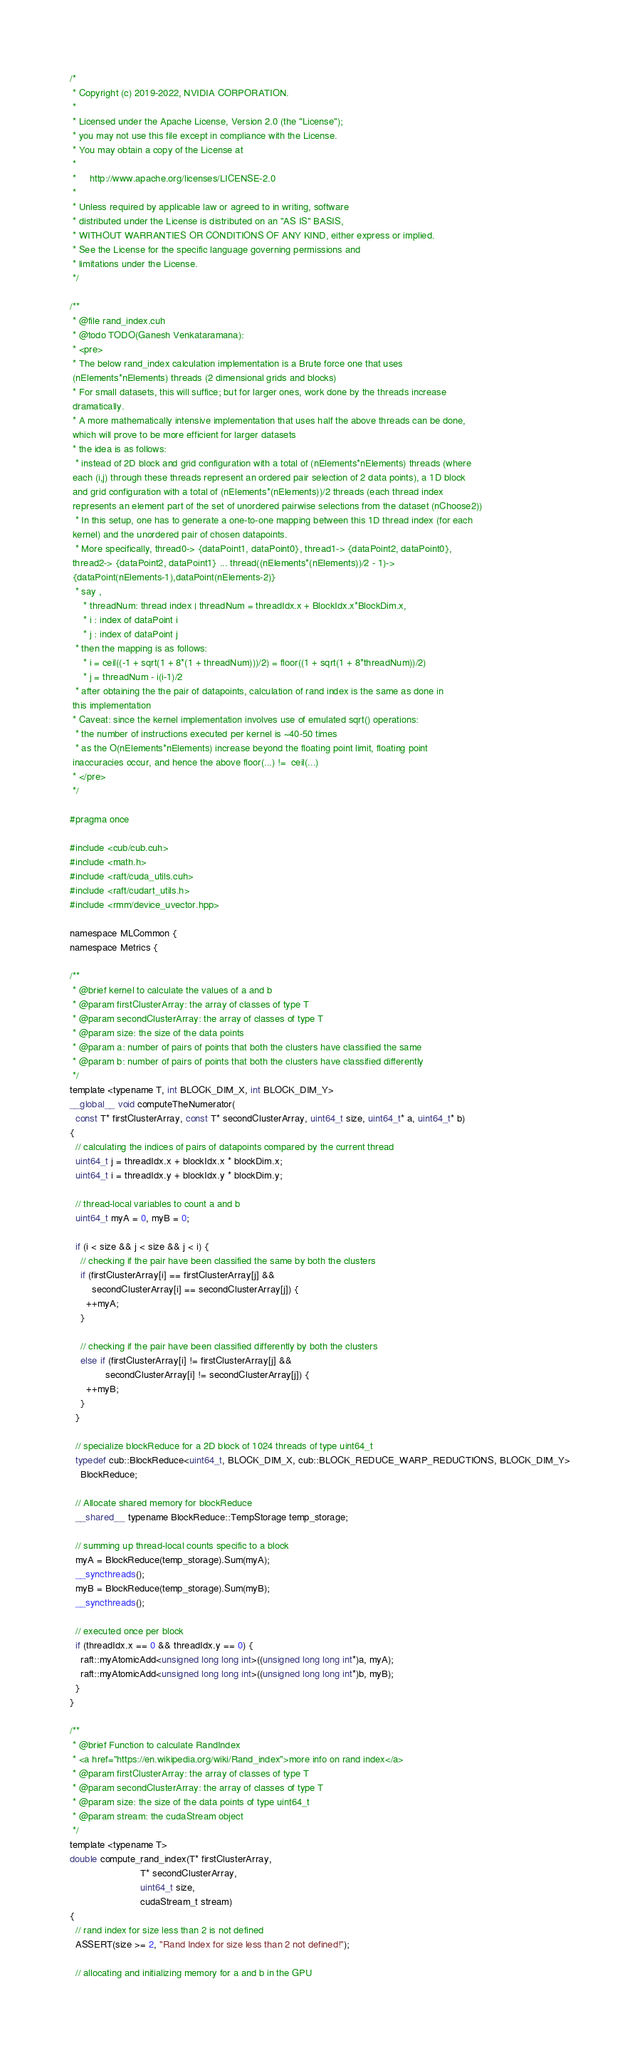Convert code to text. <code><loc_0><loc_0><loc_500><loc_500><_Cuda_>/*
 * Copyright (c) 2019-2022, NVIDIA CORPORATION.
 *
 * Licensed under the Apache License, Version 2.0 (the "License");
 * you may not use this file except in compliance with the License.
 * You may obtain a copy of the License at
 *
 *     http://www.apache.org/licenses/LICENSE-2.0
 *
 * Unless required by applicable law or agreed to in writing, software
 * distributed under the License is distributed on an "AS IS" BASIS,
 * WITHOUT WARRANTIES OR CONDITIONS OF ANY KIND, either express or implied.
 * See the License for the specific language governing permissions and
 * limitations under the License.
 */

/**
 * @file rand_index.cuh
 * @todo TODO(Ganesh Venkataramana):
 * <pre>
 * The below rand_index calculation implementation is a Brute force one that uses
 (nElements*nElements) threads (2 dimensional grids and blocks)
 * For small datasets, this will suffice; but for larger ones, work done by the threads increase
 dramatically.
 * A more mathematically intensive implementation that uses half the above threads can be done,
 which will prove to be more efficient for larger datasets
 * the idea is as follows:
  * instead of 2D block and grid configuration with a total of (nElements*nElements) threads (where
 each (i,j) through these threads represent an ordered pair selection of 2 data points), a 1D block
 and grid configuration with a total of (nElements*(nElements))/2 threads (each thread index
 represents an element part of the set of unordered pairwise selections from the dataset (nChoose2))
  * In this setup, one has to generate a one-to-one mapping between this 1D thread index (for each
 kernel) and the unordered pair of chosen datapoints.
  * More specifically, thread0-> {dataPoint1, dataPoint0}, thread1-> {dataPoint2, dataPoint0},
 thread2-> {dataPoint2, dataPoint1} ... thread((nElements*(nElements))/2 - 1)->
 {dataPoint(nElements-1),dataPoint(nElements-2)}
  * say ,
     * threadNum: thread index | threadNum = threadIdx.x + BlockIdx.x*BlockDim.x,
     * i : index of dataPoint i
     * j : index of dataPoint j
  * then the mapping is as follows:
     * i = ceil((-1 + sqrt(1 + 8*(1 + threadNum)))/2) = floor((1 + sqrt(1 + 8*threadNum))/2)
     * j = threadNum - i(i-1)/2
  * after obtaining the the pair of datapoints, calculation of rand index is the same as done in
 this implementation
 * Caveat: since the kernel implementation involves use of emulated sqrt() operations:
  * the number of instructions executed per kernel is ~40-50 times
  * as the O(nElements*nElements) increase beyond the floating point limit, floating point
 inaccuracies occur, and hence the above floor(...) !=  ceil(...)
 * </pre>
 */

#pragma once

#include <cub/cub.cuh>
#include <math.h>
#include <raft/cuda_utils.cuh>
#include <raft/cudart_utils.h>
#include <rmm/device_uvector.hpp>

namespace MLCommon {
namespace Metrics {

/**
 * @brief kernel to calculate the values of a and b
 * @param firstClusterArray: the array of classes of type T
 * @param secondClusterArray: the array of classes of type T
 * @param size: the size of the data points
 * @param a: number of pairs of points that both the clusters have classified the same
 * @param b: number of pairs of points that both the clusters have classified differently
 */
template <typename T, int BLOCK_DIM_X, int BLOCK_DIM_Y>
__global__ void computeTheNumerator(
  const T* firstClusterArray, const T* secondClusterArray, uint64_t size, uint64_t* a, uint64_t* b)
{
  // calculating the indices of pairs of datapoints compared by the current thread
  uint64_t j = threadIdx.x + blockIdx.x * blockDim.x;
  uint64_t i = threadIdx.y + blockIdx.y * blockDim.y;

  // thread-local variables to count a and b
  uint64_t myA = 0, myB = 0;

  if (i < size && j < size && j < i) {
    // checking if the pair have been classified the same by both the clusters
    if (firstClusterArray[i] == firstClusterArray[j] &&
        secondClusterArray[i] == secondClusterArray[j]) {
      ++myA;
    }

    // checking if the pair have been classified differently by both the clusters
    else if (firstClusterArray[i] != firstClusterArray[j] &&
             secondClusterArray[i] != secondClusterArray[j]) {
      ++myB;
    }
  }

  // specialize blockReduce for a 2D block of 1024 threads of type uint64_t
  typedef cub::BlockReduce<uint64_t, BLOCK_DIM_X, cub::BLOCK_REDUCE_WARP_REDUCTIONS, BLOCK_DIM_Y>
    BlockReduce;

  // Allocate shared memory for blockReduce
  __shared__ typename BlockReduce::TempStorage temp_storage;

  // summing up thread-local counts specific to a block
  myA = BlockReduce(temp_storage).Sum(myA);
  __syncthreads();
  myB = BlockReduce(temp_storage).Sum(myB);
  __syncthreads();

  // executed once per block
  if (threadIdx.x == 0 && threadIdx.y == 0) {
    raft::myAtomicAdd<unsigned long long int>((unsigned long long int*)a, myA);
    raft::myAtomicAdd<unsigned long long int>((unsigned long long int*)b, myB);
  }
}

/**
 * @brief Function to calculate RandIndex
 * <a href="https://en.wikipedia.org/wiki/Rand_index">more info on rand index</a>
 * @param firstClusterArray: the array of classes of type T
 * @param secondClusterArray: the array of classes of type T
 * @param size: the size of the data points of type uint64_t
 * @param stream: the cudaStream object
 */
template <typename T>
double compute_rand_index(T* firstClusterArray,
                          T* secondClusterArray,
                          uint64_t size,
                          cudaStream_t stream)
{
  // rand index for size less than 2 is not defined
  ASSERT(size >= 2, "Rand Index for size less than 2 not defined!");

  // allocating and initializing memory for a and b in the GPU</code> 